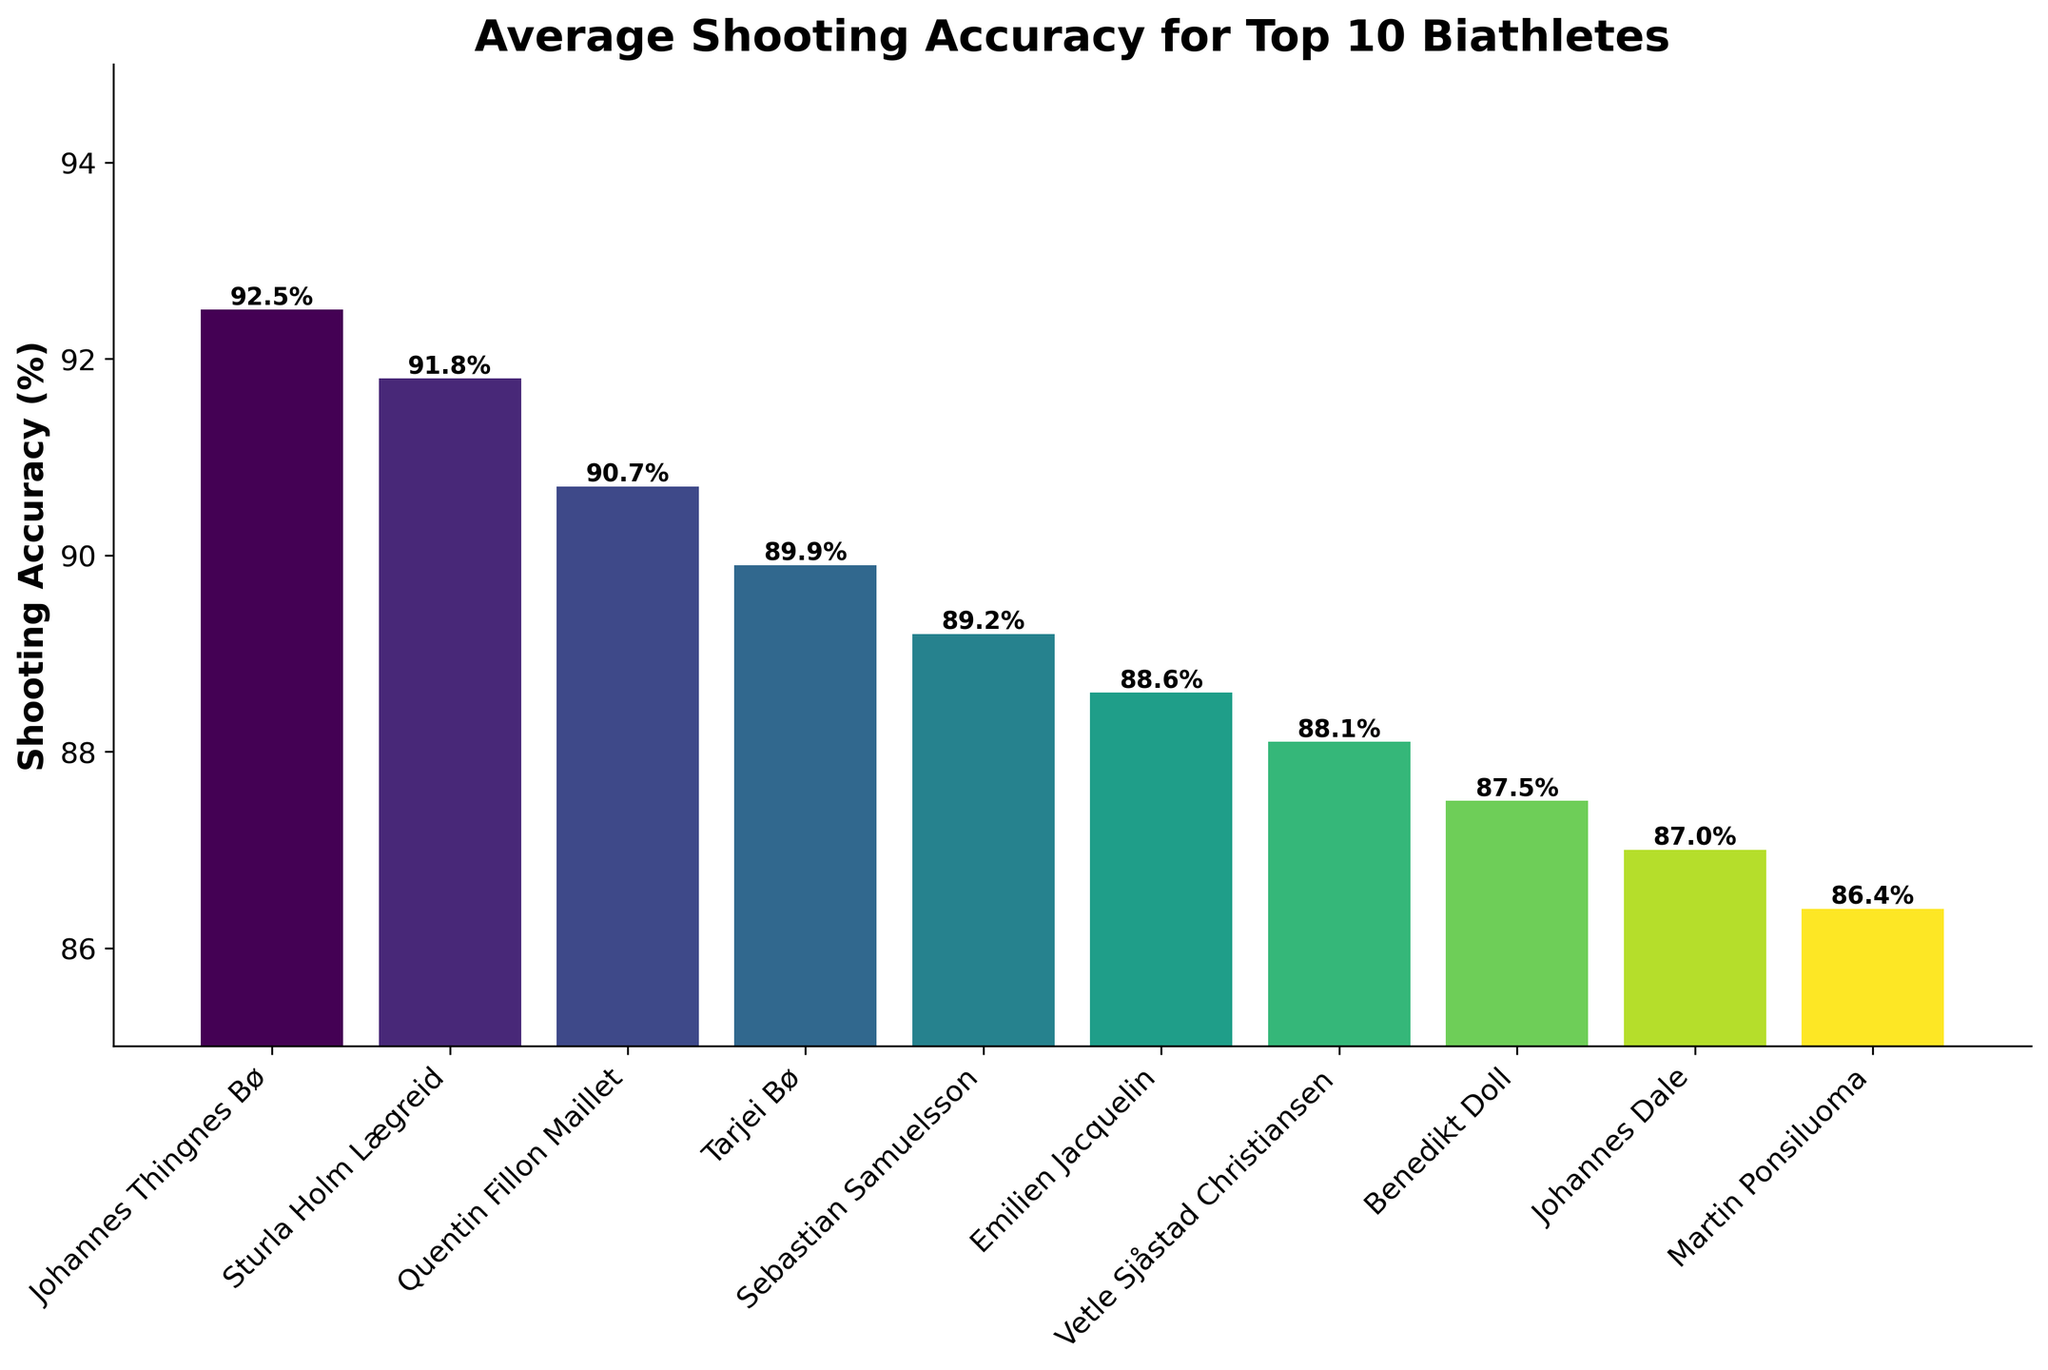What's the average shooting accuracy of the top 3 biathletes? We need to calculate the average of the accuracies for Johannes Thingnes Bø, Sturla Holm Lægreid, and Quentin Fillon Maillet. Sum their accuracies: 92.5 + 91.8 + 90.7 = 275. Then divide by 3: 275 / 3 = 91.67.
Answer: 91.67 Which biathlete has the highest shooting accuracy? Look at the bar with the greatest height and check the name. The bar for Johannes Thingnes Bø is the tallest, with an accuracy of 92.5%.
Answer: Johannes Thingnes Bø Which biathlete has the lowest shooting accuracy? Look at the bar with the shortest height and check the name. The bar for Martin Ponsiluoma is the shortest, with an accuracy of 86.4%.
Answer: Martin Ponsiluoma How many biathletes have a shooting accuracy above 90%? Count the number of bars with heights that exceed the 90% line. There are 3 bars: Johannes Thingnes Bø, Sturla Holm Lægreid, and Quentin Fillon Maillet.
Answer: 3 What's the difference in shooting accuracy between Tarjei Bø and Johannes Dale? Subtract the shooting accuracy of Johannes Dale from that of Tarjei Bø: 89.9% - 87.0% = 2.9%.
Answer: 2.9 Which biathletes have shooting accuracies between 87% and 89% inclusively? Identify the bars with heights in the range of 87% to 89%. They are Vetle Sjåstad Christiansen (88.1%), Benedikt Doll (87.5%), and Johannes Dale (87.0%).
Answer: Vetle Sjåstad Christiansen, Benedikt Doll, Johannes Dale What is the range of shooting accuracies among the top 10 biathletes? Find the difference between the highest and lowest shooting accuracies. Highest is 92.5% (Johannes Thingnes Bø) and lowest is 86.4% (Martin Ponsiluoma). Subtract: 92.5% - 86.4% = 6.1%.
Answer: 6.1 Among the top 10, which biathlete has a shooting accuracy closest to 88%? Check the bar heights around 88%. Emilien Jacquelin has an accuracy of 88.6%, closest to 88%.
Answer: Emilien Jacquelin By how much does Sebastian Samuelsson's shooting accuracy exceed Martin Ponsiluoma's? Subtract Martin Ponsiluoma's accuracy from Sebastian Samuelsson's: 89.2% - 86.4% = 2.8%.
Answer: 2.8 